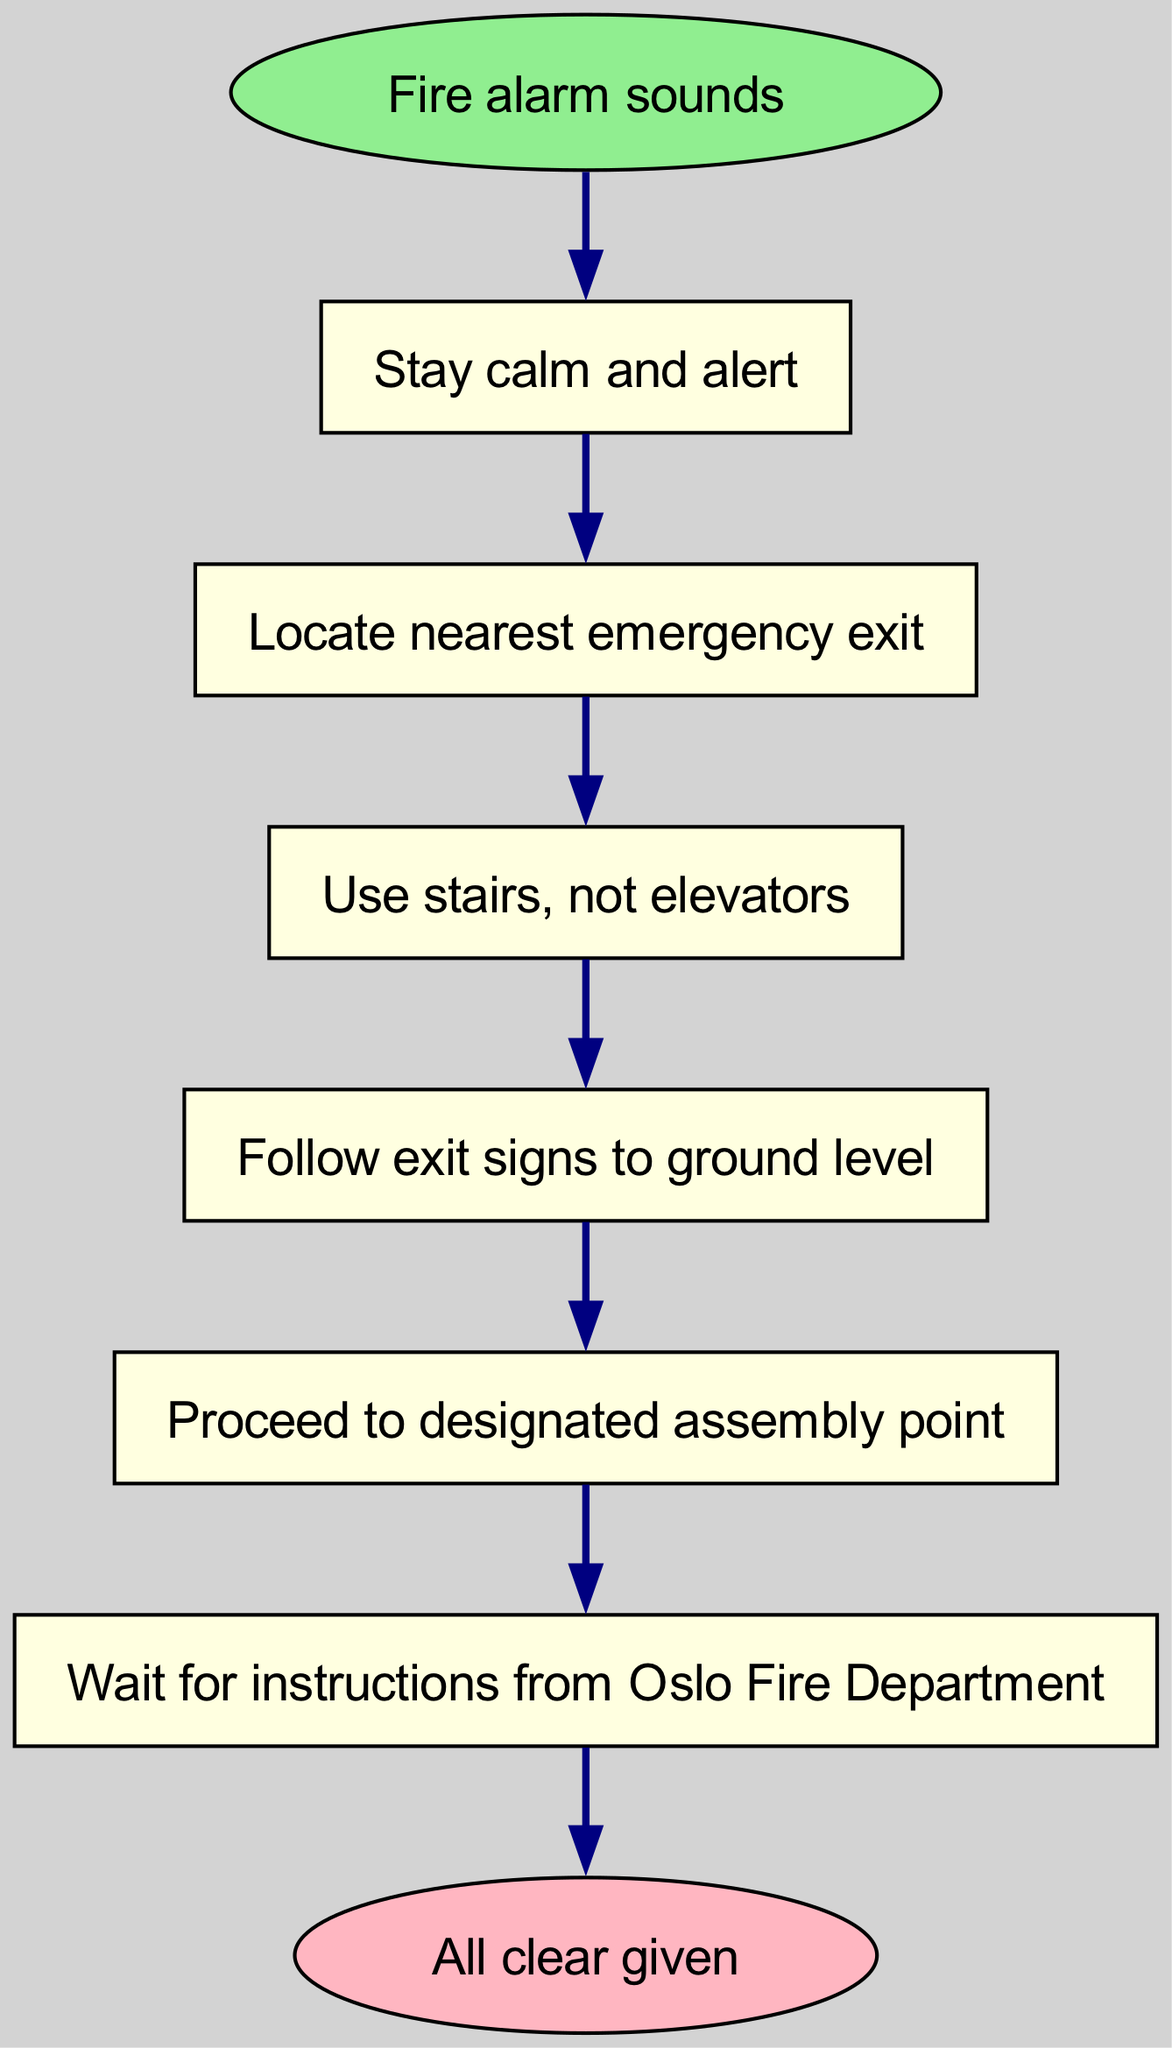What is the first step in the evacuation procedure? The diagram starts with the node labeled "Fire alarm sounds," which leads to the first step "Stay calm and alert." Therefore, the first step is directly indicated in the sequence.
Answer: Stay calm and alert How many steps are involved in the procedure? By counting the steps listed in the diagram, there are a total of six steps from "Stay calm and alert" to "Wait for instructions from Oslo Fire Department." This can be verified by observing the labels attached to each node in the steps.
Answer: Six What should you do when the fire alarm sounds? The first node in the flow chart indicates "Stay calm and alert" directly following the "Fire alarm sounds." This is the immediate action that should be taken according to the sequence of steps.
Answer: Stay calm and alert What is the last action before receiving instructions from the Oslo Fire Department? In the flow of the diagram, the last step prior to "Wait for instructions from Oslo Fire Department" is "Proceed to designated assembly point." This shows the necessary action must be taken as the last step before instructions.
Answer: Proceed to designated assembly point Which mode of transportation is prohibited during the evacuation? The diagram specifies in the third step "Use stairs, not elevators," directly prohibiting the use of elevators during the evacuation process. This is clearly stated in the sequence of instructions.
Answer: Elevators 